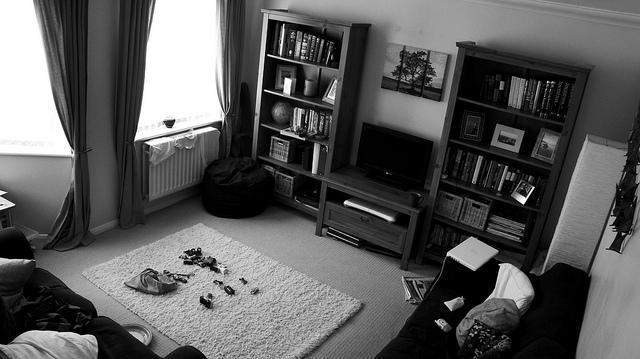How many couches are there?
Give a very brief answer. 2. How many books are there?
Give a very brief answer. 2. 